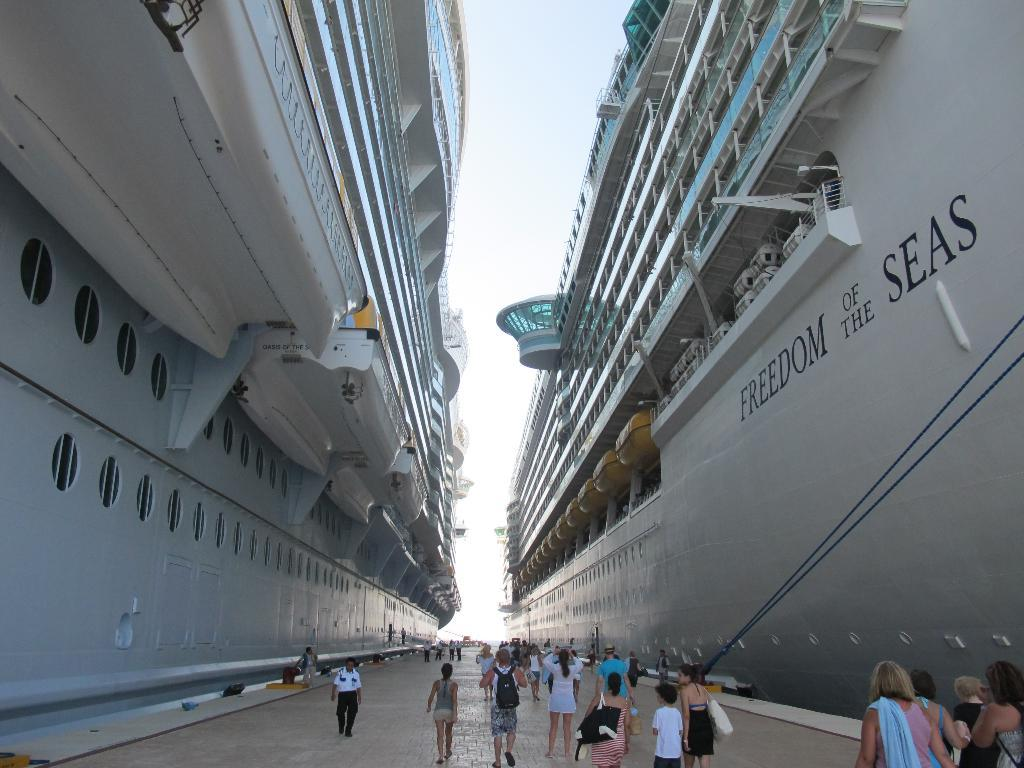Provide a one-sentence caption for the provided image. the word seas on the side of a large ship. 